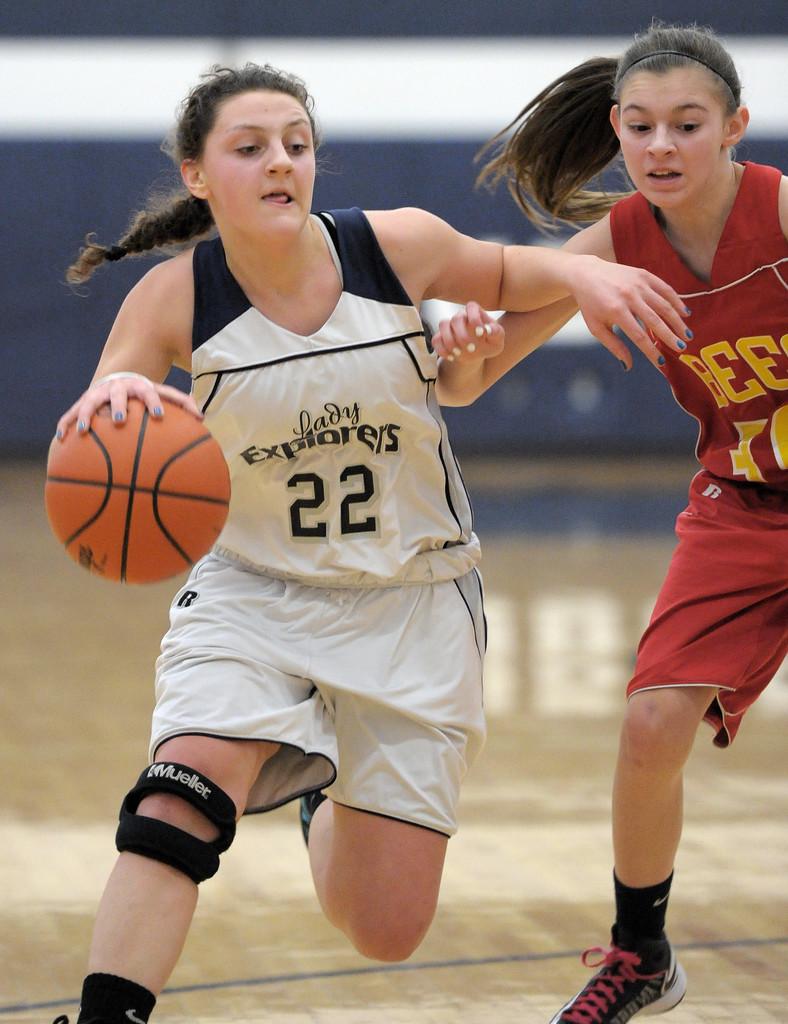What is the number of the athlete in the white uniform?
Provide a short and direct response. 22. Which team does number 22 play for?
Ensure brevity in your answer.  Lady explorers. 